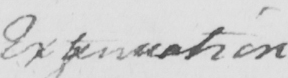Transcribe the text shown in this historical manuscript line. Extenuation 